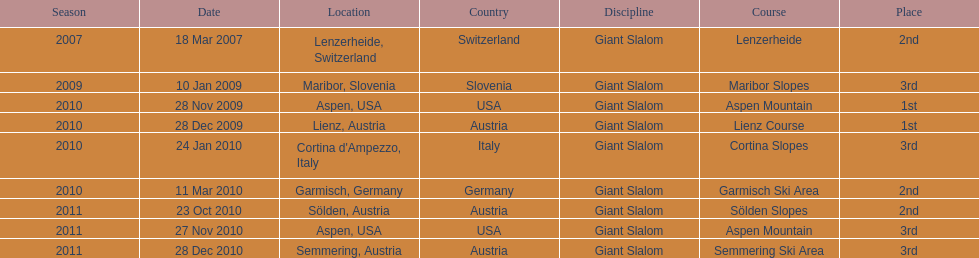What is the only location in the us? Aspen. 